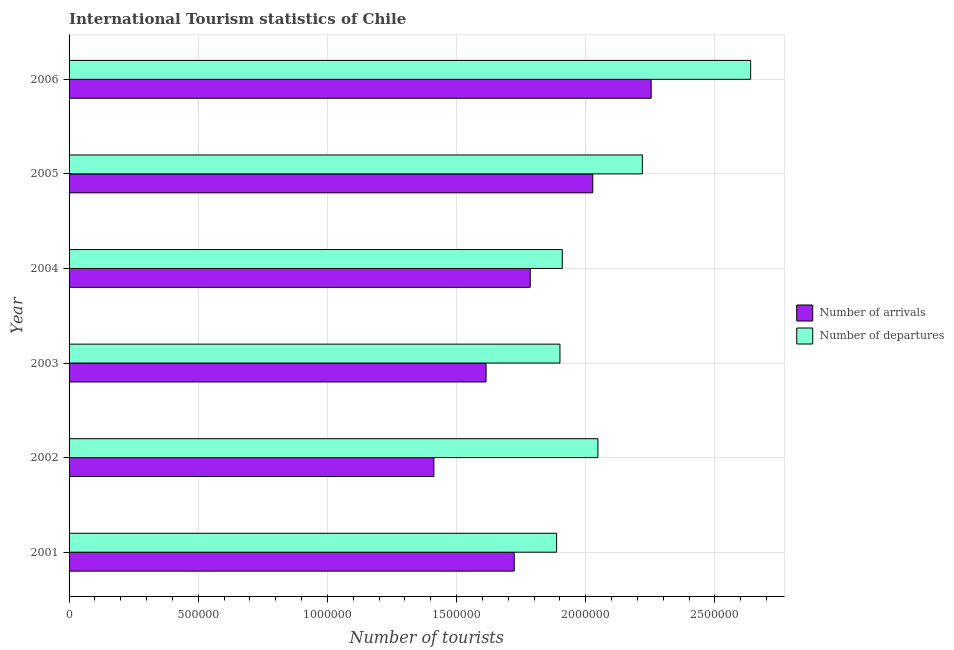How many different coloured bars are there?
Keep it short and to the point. 2. How many groups of bars are there?
Provide a succinct answer. 6. Are the number of bars on each tick of the Y-axis equal?
Your answer should be compact. Yes. How many bars are there on the 2nd tick from the bottom?
Your response must be concise. 2. What is the number of tourist departures in 2001?
Give a very brief answer. 1.89e+06. Across all years, what is the maximum number of tourist departures?
Provide a succinct answer. 2.64e+06. Across all years, what is the minimum number of tourist arrivals?
Your answer should be compact. 1.41e+06. In which year was the number of tourist departures minimum?
Give a very brief answer. 2001. What is the total number of tourist arrivals in the graph?
Your answer should be very brief. 1.08e+07. What is the difference between the number of tourist arrivals in 2004 and that in 2006?
Offer a terse response. -4.68e+05. What is the difference between the number of tourist departures in 2006 and the number of tourist arrivals in 2002?
Give a very brief answer. 1.23e+06. What is the average number of tourist arrivals per year?
Your response must be concise. 1.80e+06. In the year 2006, what is the difference between the number of tourist arrivals and number of tourist departures?
Give a very brief answer. -3.85e+05. In how many years, is the number of tourist departures greater than 400000 ?
Ensure brevity in your answer.  6. What is the ratio of the number of tourist departures in 2002 to that in 2006?
Offer a very short reply. 0.78. What is the difference between the highest and the second highest number of tourist departures?
Provide a succinct answer. 4.19e+05. What is the difference between the highest and the lowest number of tourist departures?
Your answer should be compact. 7.51e+05. In how many years, is the number of tourist arrivals greater than the average number of tourist arrivals taken over all years?
Give a very brief answer. 2. What does the 2nd bar from the top in 2004 represents?
Offer a very short reply. Number of arrivals. What does the 1st bar from the bottom in 2002 represents?
Your answer should be compact. Number of arrivals. Are all the bars in the graph horizontal?
Your answer should be compact. Yes. How many years are there in the graph?
Your answer should be compact. 6. What is the difference between two consecutive major ticks on the X-axis?
Offer a terse response. 5.00e+05. Does the graph contain any zero values?
Give a very brief answer. No. Where does the legend appear in the graph?
Offer a terse response. Center right. How are the legend labels stacked?
Ensure brevity in your answer.  Vertical. What is the title of the graph?
Ensure brevity in your answer.  International Tourism statistics of Chile. What is the label or title of the X-axis?
Provide a short and direct response. Number of tourists. What is the Number of tourists of Number of arrivals in 2001?
Keep it short and to the point. 1.72e+06. What is the Number of tourists in Number of departures in 2001?
Ensure brevity in your answer.  1.89e+06. What is the Number of tourists in Number of arrivals in 2002?
Offer a very short reply. 1.41e+06. What is the Number of tourists of Number of departures in 2002?
Your answer should be compact. 2.05e+06. What is the Number of tourists in Number of arrivals in 2003?
Ensure brevity in your answer.  1.61e+06. What is the Number of tourists of Number of departures in 2003?
Give a very brief answer. 1.90e+06. What is the Number of tourists in Number of arrivals in 2004?
Keep it short and to the point. 1.78e+06. What is the Number of tourists of Number of departures in 2004?
Your answer should be very brief. 1.91e+06. What is the Number of tourists of Number of arrivals in 2005?
Provide a succinct answer. 2.03e+06. What is the Number of tourists of Number of departures in 2005?
Keep it short and to the point. 2.22e+06. What is the Number of tourists in Number of arrivals in 2006?
Make the answer very short. 2.25e+06. What is the Number of tourists in Number of departures in 2006?
Your answer should be compact. 2.64e+06. Across all years, what is the maximum Number of tourists in Number of arrivals?
Offer a very short reply. 2.25e+06. Across all years, what is the maximum Number of tourists in Number of departures?
Make the answer very short. 2.64e+06. Across all years, what is the minimum Number of tourists of Number of arrivals?
Offer a terse response. 1.41e+06. Across all years, what is the minimum Number of tourists in Number of departures?
Keep it short and to the point. 1.89e+06. What is the total Number of tourists in Number of arrivals in the graph?
Keep it short and to the point. 1.08e+07. What is the total Number of tourists of Number of departures in the graph?
Offer a very short reply. 1.26e+07. What is the difference between the Number of tourists in Number of arrivals in 2001 and that in 2002?
Provide a succinct answer. 3.11e+05. What is the difference between the Number of tourists in Number of arrivals in 2001 and that in 2003?
Your response must be concise. 1.09e+05. What is the difference between the Number of tourists in Number of departures in 2001 and that in 2003?
Offer a very short reply. -1.30e+04. What is the difference between the Number of tourists in Number of arrivals in 2001 and that in 2004?
Offer a terse response. -6.20e+04. What is the difference between the Number of tourists in Number of departures in 2001 and that in 2004?
Give a very brief answer. -2.20e+04. What is the difference between the Number of tourists of Number of arrivals in 2001 and that in 2005?
Keep it short and to the point. -3.04e+05. What is the difference between the Number of tourists in Number of departures in 2001 and that in 2005?
Make the answer very short. -3.32e+05. What is the difference between the Number of tourists of Number of arrivals in 2001 and that in 2006?
Provide a succinct answer. -5.30e+05. What is the difference between the Number of tourists in Number of departures in 2001 and that in 2006?
Give a very brief answer. -7.51e+05. What is the difference between the Number of tourists of Number of arrivals in 2002 and that in 2003?
Ensure brevity in your answer.  -2.02e+05. What is the difference between the Number of tourists of Number of departures in 2002 and that in 2003?
Make the answer very short. 1.47e+05. What is the difference between the Number of tourists in Number of arrivals in 2002 and that in 2004?
Offer a very short reply. -3.73e+05. What is the difference between the Number of tourists of Number of departures in 2002 and that in 2004?
Your response must be concise. 1.38e+05. What is the difference between the Number of tourists in Number of arrivals in 2002 and that in 2005?
Offer a very short reply. -6.15e+05. What is the difference between the Number of tourists in Number of departures in 2002 and that in 2005?
Offer a terse response. -1.72e+05. What is the difference between the Number of tourists in Number of arrivals in 2002 and that in 2006?
Ensure brevity in your answer.  -8.41e+05. What is the difference between the Number of tourists in Number of departures in 2002 and that in 2006?
Ensure brevity in your answer.  -5.91e+05. What is the difference between the Number of tourists in Number of arrivals in 2003 and that in 2004?
Make the answer very short. -1.71e+05. What is the difference between the Number of tourists in Number of departures in 2003 and that in 2004?
Make the answer very short. -9000. What is the difference between the Number of tourists of Number of arrivals in 2003 and that in 2005?
Your answer should be very brief. -4.13e+05. What is the difference between the Number of tourists of Number of departures in 2003 and that in 2005?
Offer a very short reply. -3.19e+05. What is the difference between the Number of tourists of Number of arrivals in 2003 and that in 2006?
Your answer should be very brief. -6.39e+05. What is the difference between the Number of tourists in Number of departures in 2003 and that in 2006?
Your answer should be very brief. -7.38e+05. What is the difference between the Number of tourists in Number of arrivals in 2004 and that in 2005?
Provide a short and direct response. -2.42e+05. What is the difference between the Number of tourists in Number of departures in 2004 and that in 2005?
Keep it short and to the point. -3.10e+05. What is the difference between the Number of tourists in Number of arrivals in 2004 and that in 2006?
Offer a terse response. -4.68e+05. What is the difference between the Number of tourists in Number of departures in 2004 and that in 2006?
Offer a terse response. -7.29e+05. What is the difference between the Number of tourists of Number of arrivals in 2005 and that in 2006?
Your answer should be very brief. -2.26e+05. What is the difference between the Number of tourists of Number of departures in 2005 and that in 2006?
Your answer should be compact. -4.19e+05. What is the difference between the Number of tourists in Number of arrivals in 2001 and the Number of tourists in Number of departures in 2002?
Keep it short and to the point. -3.24e+05. What is the difference between the Number of tourists of Number of arrivals in 2001 and the Number of tourists of Number of departures in 2003?
Provide a short and direct response. -1.77e+05. What is the difference between the Number of tourists of Number of arrivals in 2001 and the Number of tourists of Number of departures in 2004?
Provide a succinct answer. -1.86e+05. What is the difference between the Number of tourists of Number of arrivals in 2001 and the Number of tourists of Number of departures in 2005?
Make the answer very short. -4.96e+05. What is the difference between the Number of tourists in Number of arrivals in 2001 and the Number of tourists in Number of departures in 2006?
Offer a terse response. -9.15e+05. What is the difference between the Number of tourists of Number of arrivals in 2002 and the Number of tourists of Number of departures in 2003?
Keep it short and to the point. -4.88e+05. What is the difference between the Number of tourists in Number of arrivals in 2002 and the Number of tourists in Number of departures in 2004?
Offer a terse response. -4.97e+05. What is the difference between the Number of tourists of Number of arrivals in 2002 and the Number of tourists of Number of departures in 2005?
Your answer should be very brief. -8.07e+05. What is the difference between the Number of tourists of Number of arrivals in 2002 and the Number of tourists of Number of departures in 2006?
Keep it short and to the point. -1.23e+06. What is the difference between the Number of tourists in Number of arrivals in 2003 and the Number of tourists in Number of departures in 2004?
Provide a short and direct response. -2.95e+05. What is the difference between the Number of tourists of Number of arrivals in 2003 and the Number of tourists of Number of departures in 2005?
Keep it short and to the point. -6.05e+05. What is the difference between the Number of tourists of Number of arrivals in 2003 and the Number of tourists of Number of departures in 2006?
Provide a short and direct response. -1.02e+06. What is the difference between the Number of tourists of Number of arrivals in 2004 and the Number of tourists of Number of departures in 2005?
Provide a succinct answer. -4.34e+05. What is the difference between the Number of tourists of Number of arrivals in 2004 and the Number of tourists of Number of departures in 2006?
Ensure brevity in your answer.  -8.53e+05. What is the difference between the Number of tourists in Number of arrivals in 2005 and the Number of tourists in Number of departures in 2006?
Offer a very short reply. -6.11e+05. What is the average Number of tourists of Number of arrivals per year?
Your response must be concise. 1.80e+06. What is the average Number of tourists of Number of departures per year?
Offer a terse response. 2.10e+06. In the year 2001, what is the difference between the Number of tourists of Number of arrivals and Number of tourists of Number of departures?
Offer a terse response. -1.64e+05. In the year 2002, what is the difference between the Number of tourists of Number of arrivals and Number of tourists of Number of departures?
Your answer should be very brief. -6.35e+05. In the year 2003, what is the difference between the Number of tourists of Number of arrivals and Number of tourists of Number of departures?
Keep it short and to the point. -2.86e+05. In the year 2004, what is the difference between the Number of tourists in Number of arrivals and Number of tourists in Number of departures?
Keep it short and to the point. -1.24e+05. In the year 2005, what is the difference between the Number of tourists in Number of arrivals and Number of tourists in Number of departures?
Offer a terse response. -1.92e+05. In the year 2006, what is the difference between the Number of tourists in Number of arrivals and Number of tourists in Number of departures?
Offer a very short reply. -3.85e+05. What is the ratio of the Number of tourists in Number of arrivals in 2001 to that in 2002?
Ensure brevity in your answer.  1.22. What is the ratio of the Number of tourists of Number of departures in 2001 to that in 2002?
Provide a succinct answer. 0.92. What is the ratio of the Number of tourists of Number of arrivals in 2001 to that in 2003?
Ensure brevity in your answer.  1.07. What is the ratio of the Number of tourists of Number of departures in 2001 to that in 2003?
Offer a very short reply. 0.99. What is the ratio of the Number of tourists in Number of arrivals in 2001 to that in 2004?
Offer a terse response. 0.97. What is the ratio of the Number of tourists of Number of arrivals in 2001 to that in 2005?
Keep it short and to the point. 0.85. What is the ratio of the Number of tourists of Number of departures in 2001 to that in 2005?
Provide a succinct answer. 0.85. What is the ratio of the Number of tourists of Number of arrivals in 2001 to that in 2006?
Offer a terse response. 0.76. What is the ratio of the Number of tourists of Number of departures in 2001 to that in 2006?
Your answer should be compact. 0.72. What is the ratio of the Number of tourists in Number of arrivals in 2002 to that in 2003?
Make the answer very short. 0.87. What is the ratio of the Number of tourists of Number of departures in 2002 to that in 2003?
Keep it short and to the point. 1.08. What is the ratio of the Number of tourists of Number of arrivals in 2002 to that in 2004?
Your answer should be very brief. 0.79. What is the ratio of the Number of tourists in Number of departures in 2002 to that in 2004?
Keep it short and to the point. 1.07. What is the ratio of the Number of tourists of Number of arrivals in 2002 to that in 2005?
Provide a succinct answer. 0.7. What is the ratio of the Number of tourists in Number of departures in 2002 to that in 2005?
Give a very brief answer. 0.92. What is the ratio of the Number of tourists in Number of arrivals in 2002 to that in 2006?
Ensure brevity in your answer.  0.63. What is the ratio of the Number of tourists of Number of departures in 2002 to that in 2006?
Provide a succinct answer. 0.78. What is the ratio of the Number of tourists in Number of arrivals in 2003 to that in 2004?
Give a very brief answer. 0.9. What is the ratio of the Number of tourists of Number of arrivals in 2003 to that in 2005?
Ensure brevity in your answer.  0.8. What is the ratio of the Number of tourists in Number of departures in 2003 to that in 2005?
Your answer should be very brief. 0.86. What is the ratio of the Number of tourists of Number of arrivals in 2003 to that in 2006?
Provide a short and direct response. 0.72. What is the ratio of the Number of tourists in Number of departures in 2003 to that in 2006?
Your response must be concise. 0.72. What is the ratio of the Number of tourists in Number of arrivals in 2004 to that in 2005?
Offer a very short reply. 0.88. What is the ratio of the Number of tourists in Number of departures in 2004 to that in 2005?
Offer a very short reply. 0.86. What is the ratio of the Number of tourists of Number of arrivals in 2004 to that in 2006?
Offer a terse response. 0.79. What is the ratio of the Number of tourists of Number of departures in 2004 to that in 2006?
Offer a very short reply. 0.72. What is the ratio of the Number of tourists of Number of arrivals in 2005 to that in 2006?
Your answer should be compact. 0.9. What is the ratio of the Number of tourists in Number of departures in 2005 to that in 2006?
Your answer should be compact. 0.84. What is the difference between the highest and the second highest Number of tourists of Number of arrivals?
Give a very brief answer. 2.26e+05. What is the difference between the highest and the second highest Number of tourists of Number of departures?
Provide a succinct answer. 4.19e+05. What is the difference between the highest and the lowest Number of tourists in Number of arrivals?
Provide a succinct answer. 8.41e+05. What is the difference between the highest and the lowest Number of tourists in Number of departures?
Your answer should be very brief. 7.51e+05. 